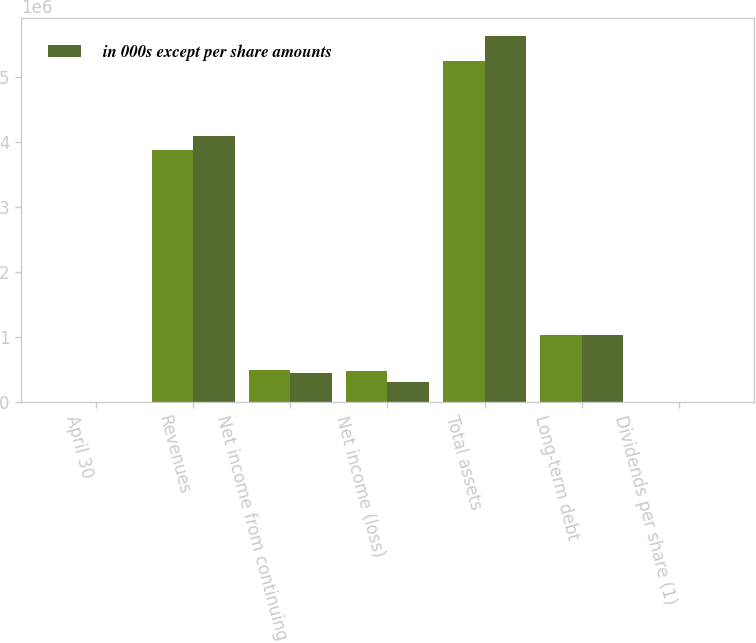Convert chart to OTSL. <chart><loc_0><loc_0><loc_500><loc_500><stacked_bar_chart><ecel><fcel>April 30<fcel>Revenues<fcel>Net income from continuing<fcel>Net income (loss)<fcel>Total assets<fcel>Long-term debt<fcel>Dividends per share (1)<nl><fcel>nan<fcel>2010<fcel>3.87433e+06<fcel>488946<fcel>479242<fcel>5.23432e+06<fcel>1.03514e+06<fcel>0.75<nl><fcel>in 000s except per share amounts<fcel>2008<fcel>4.08663e+06<fcel>445947<fcel>308647<fcel>5.62342e+06<fcel>1.03178e+06<fcel>0.56<nl></chart> 